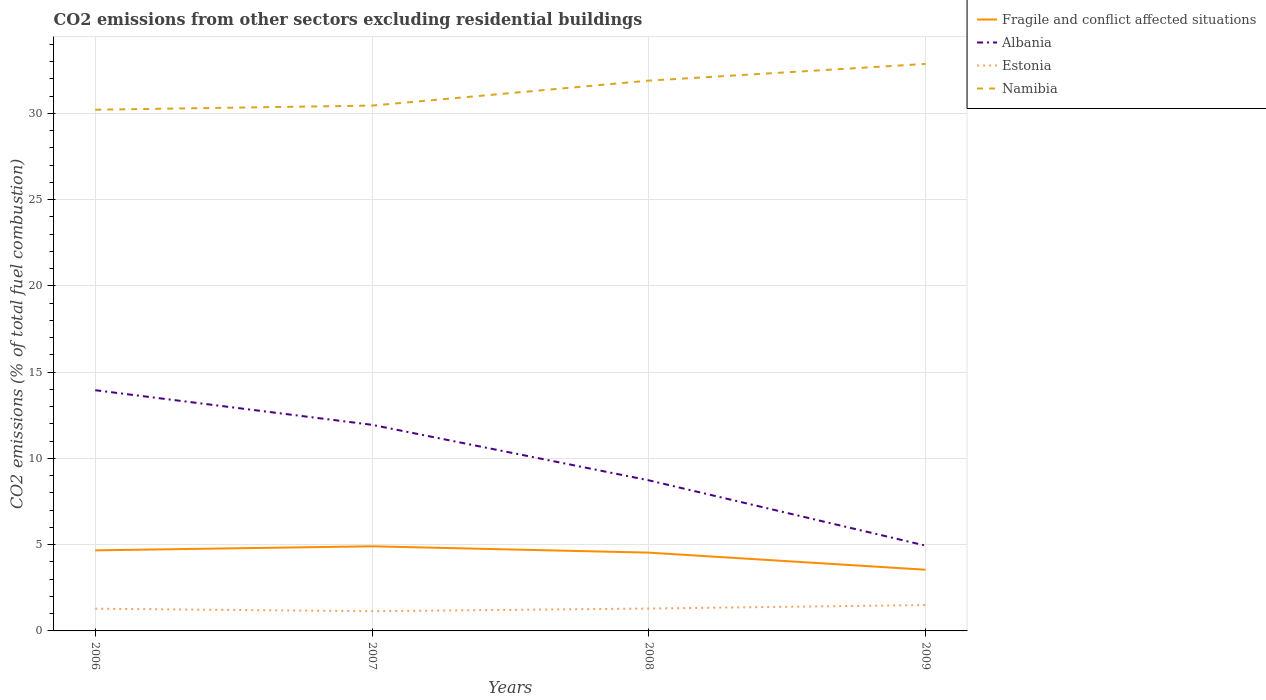How many different coloured lines are there?
Make the answer very short. 4. Does the line corresponding to Fragile and conflict affected situations intersect with the line corresponding to Namibia?
Your answer should be very brief. No. Is the number of lines equal to the number of legend labels?
Provide a succinct answer. Yes. Across all years, what is the maximum total CO2 emitted in Estonia?
Provide a succinct answer. 1.14. In which year was the total CO2 emitted in Namibia maximum?
Provide a succinct answer. 2006. What is the total total CO2 emitted in Estonia in the graph?
Your response must be concise. -0.01. What is the difference between the highest and the second highest total CO2 emitted in Namibia?
Your response must be concise. 2.65. What is the difference between the highest and the lowest total CO2 emitted in Estonia?
Your answer should be very brief. 1. Is the total CO2 emitted in Namibia strictly greater than the total CO2 emitted in Fragile and conflict affected situations over the years?
Your answer should be very brief. No. How many years are there in the graph?
Ensure brevity in your answer.  4. What is the difference between two consecutive major ticks on the Y-axis?
Ensure brevity in your answer.  5. Does the graph contain grids?
Your answer should be compact. Yes. How many legend labels are there?
Provide a succinct answer. 4. What is the title of the graph?
Your answer should be compact. CO2 emissions from other sectors excluding residential buildings. Does "Malawi" appear as one of the legend labels in the graph?
Provide a short and direct response. No. What is the label or title of the Y-axis?
Ensure brevity in your answer.  CO2 emissions (% of total fuel combustion). What is the CO2 emissions (% of total fuel combustion) of Fragile and conflict affected situations in 2006?
Your answer should be very brief. 4.67. What is the CO2 emissions (% of total fuel combustion) of Albania in 2006?
Ensure brevity in your answer.  13.95. What is the CO2 emissions (% of total fuel combustion) of Estonia in 2006?
Your answer should be compact. 1.29. What is the CO2 emissions (% of total fuel combustion) of Namibia in 2006?
Keep it short and to the point. 30.21. What is the CO2 emissions (% of total fuel combustion) of Fragile and conflict affected situations in 2007?
Give a very brief answer. 4.91. What is the CO2 emissions (% of total fuel combustion) of Albania in 2007?
Offer a terse response. 11.95. What is the CO2 emissions (% of total fuel combustion) in Estonia in 2007?
Provide a short and direct response. 1.14. What is the CO2 emissions (% of total fuel combustion) in Namibia in 2007?
Keep it short and to the point. 30.45. What is the CO2 emissions (% of total fuel combustion) of Fragile and conflict affected situations in 2008?
Give a very brief answer. 4.54. What is the CO2 emissions (% of total fuel combustion) in Albania in 2008?
Make the answer very short. 8.73. What is the CO2 emissions (% of total fuel combustion) in Estonia in 2008?
Give a very brief answer. 1.3. What is the CO2 emissions (% of total fuel combustion) of Namibia in 2008?
Offer a very short reply. 31.9. What is the CO2 emissions (% of total fuel combustion) in Fragile and conflict affected situations in 2009?
Your answer should be very brief. 3.55. What is the CO2 emissions (% of total fuel combustion) of Albania in 2009?
Offer a very short reply. 4.95. What is the CO2 emissions (% of total fuel combustion) of Estonia in 2009?
Make the answer very short. 1.5. What is the CO2 emissions (% of total fuel combustion) in Namibia in 2009?
Keep it short and to the point. 32.87. Across all years, what is the maximum CO2 emissions (% of total fuel combustion) of Fragile and conflict affected situations?
Your response must be concise. 4.91. Across all years, what is the maximum CO2 emissions (% of total fuel combustion) of Albania?
Give a very brief answer. 13.95. Across all years, what is the maximum CO2 emissions (% of total fuel combustion) of Estonia?
Your answer should be very brief. 1.5. Across all years, what is the maximum CO2 emissions (% of total fuel combustion) in Namibia?
Your answer should be very brief. 32.87. Across all years, what is the minimum CO2 emissions (% of total fuel combustion) of Fragile and conflict affected situations?
Ensure brevity in your answer.  3.55. Across all years, what is the minimum CO2 emissions (% of total fuel combustion) of Albania?
Your answer should be compact. 4.95. Across all years, what is the minimum CO2 emissions (% of total fuel combustion) in Estonia?
Offer a very short reply. 1.14. Across all years, what is the minimum CO2 emissions (% of total fuel combustion) in Namibia?
Keep it short and to the point. 30.21. What is the total CO2 emissions (% of total fuel combustion) of Fragile and conflict affected situations in the graph?
Your answer should be compact. 17.66. What is the total CO2 emissions (% of total fuel combustion) in Albania in the graph?
Offer a terse response. 39.58. What is the total CO2 emissions (% of total fuel combustion) in Estonia in the graph?
Give a very brief answer. 5.23. What is the total CO2 emissions (% of total fuel combustion) in Namibia in the graph?
Make the answer very short. 125.43. What is the difference between the CO2 emissions (% of total fuel combustion) of Fragile and conflict affected situations in 2006 and that in 2007?
Your answer should be very brief. -0.23. What is the difference between the CO2 emissions (% of total fuel combustion) of Albania in 2006 and that in 2007?
Ensure brevity in your answer.  2.01. What is the difference between the CO2 emissions (% of total fuel combustion) of Estonia in 2006 and that in 2007?
Provide a short and direct response. 0.15. What is the difference between the CO2 emissions (% of total fuel combustion) in Namibia in 2006 and that in 2007?
Your answer should be compact. -0.24. What is the difference between the CO2 emissions (% of total fuel combustion) in Fragile and conflict affected situations in 2006 and that in 2008?
Keep it short and to the point. 0.13. What is the difference between the CO2 emissions (% of total fuel combustion) in Albania in 2006 and that in 2008?
Make the answer very short. 5.22. What is the difference between the CO2 emissions (% of total fuel combustion) of Estonia in 2006 and that in 2008?
Provide a succinct answer. -0.01. What is the difference between the CO2 emissions (% of total fuel combustion) in Namibia in 2006 and that in 2008?
Ensure brevity in your answer.  -1.69. What is the difference between the CO2 emissions (% of total fuel combustion) of Fragile and conflict affected situations in 2006 and that in 2009?
Provide a succinct answer. 1.12. What is the difference between the CO2 emissions (% of total fuel combustion) in Albania in 2006 and that in 2009?
Give a very brief answer. 9.01. What is the difference between the CO2 emissions (% of total fuel combustion) in Estonia in 2006 and that in 2009?
Your answer should be compact. -0.21. What is the difference between the CO2 emissions (% of total fuel combustion) of Namibia in 2006 and that in 2009?
Provide a short and direct response. -2.65. What is the difference between the CO2 emissions (% of total fuel combustion) of Fragile and conflict affected situations in 2007 and that in 2008?
Your answer should be compact. 0.37. What is the difference between the CO2 emissions (% of total fuel combustion) in Albania in 2007 and that in 2008?
Your answer should be very brief. 3.22. What is the difference between the CO2 emissions (% of total fuel combustion) in Estonia in 2007 and that in 2008?
Provide a succinct answer. -0.16. What is the difference between the CO2 emissions (% of total fuel combustion) of Namibia in 2007 and that in 2008?
Your response must be concise. -1.45. What is the difference between the CO2 emissions (% of total fuel combustion) in Fragile and conflict affected situations in 2007 and that in 2009?
Provide a succinct answer. 1.36. What is the difference between the CO2 emissions (% of total fuel combustion) of Albania in 2007 and that in 2009?
Your answer should be compact. 7. What is the difference between the CO2 emissions (% of total fuel combustion) of Estonia in 2007 and that in 2009?
Make the answer very short. -0.36. What is the difference between the CO2 emissions (% of total fuel combustion) of Namibia in 2007 and that in 2009?
Keep it short and to the point. -2.41. What is the difference between the CO2 emissions (% of total fuel combustion) of Albania in 2008 and that in 2009?
Provide a succinct answer. 3.79. What is the difference between the CO2 emissions (% of total fuel combustion) of Estonia in 2008 and that in 2009?
Ensure brevity in your answer.  -0.2. What is the difference between the CO2 emissions (% of total fuel combustion) of Namibia in 2008 and that in 2009?
Ensure brevity in your answer.  -0.97. What is the difference between the CO2 emissions (% of total fuel combustion) of Fragile and conflict affected situations in 2006 and the CO2 emissions (% of total fuel combustion) of Albania in 2007?
Provide a short and direct response. -7.28. What is the difference between the CO2 emissions (% of total fuel combustion) in Fragile and conflict affected situations in 2006 and the CO2 emissions (% of total fuel combustion) in Estonia in 2007?
Your answer should be very brief. 3.53. What is the difference between the CO2 emissions (% of total fuel combustion) in Fragile and conflict affected situations in 2006 and the CO2 emissions (% of total fuel combustion) in Namibia in 2007?
Give a very brief answer. -25.78. What is the difference between the CO2 emissions (% of total fuel combustion) in Albania in 2006 and the CO2 emissions (% of total fuel combustion) in Estonia in 2007?
Keep it short and to the point. 12.81. What is the difference between the CO2 emissions (% of total fuel combustion) of Albania in 2006 and the CO2 emissions (% of total fuel combustion) of Namibia in 2007?
Offer a very short reply. -16.5. What is the difference between the CO2 emissions (% of total fuel combustion) in Estonia in 2006 and the CO2 emissions (% of total fuel combustion) in Namibia in 2007?
Keep it short and to the point. -29.16. What is the difference between the CO2 emissions (% of total fuel combustion) in Fragile and conflict affected situations in 2006 and the CO2 emissions (% of total fuel combustion) in Albania in 2008?
Keep it short and to the point. -4.06. What is the difference between the CO2 emissions (% of total fuel combustion) in Fragile and conflict affected situations in 2006 and the CO2 emissions (% of total fuel combustion) in Estonia in 2008?
Your answer should be very brief. 3.37. What is the difference between the CO2 emissions (% of total fuel combustion) of Fragile and conflict affected situations in 2006 and the CO2 emissions (% of total fuel combustion) of Namibia in 2008?
Offer a terse response. -27.23. What is the difference between the CO2 emissions (% of total fuel combustion) of Albania in 2006 and the CO2 emissions (% of total fuel combustion) of Estonia in 2008?
Give a very brief answer. 12.66. What is the difference between the CO2 emissions (% of total fuel combustion) in Albania in 2006 and the CO2 emissions (% of total fuel combustion) in Namibia in 2008?
Keep it short and to the point. -17.95. What is the difference between the CO2 emissions (% of total fuel combustion) in Estonia in 2006 and the CO2 emissions (% of total fuel combustion) in Namibia in 2008?
Your answer should be compact. -30.61. What is the difference between the CO2 emissions (% of total fuel combustion) in Fragile and conflict affected situations in 2006 and the CO2 emissions (% of total fuel combustion) in Albania in 2009?
Make the answer very short. -0.27. What is the difference between the CO2 emissions (% of total fuel combustion) in Fragile and conflict affected situations in 2006 and the CO2 emissions (% of total fuel combustion) in Estonia in 2009?
Make the answer very short. 3.17. What is the difference between the CO2 emissions (% of total fuel combustion) of Fragile and conflict affected situations in 2006 and the CO2 emissions (% of total fuel combustion) of Namibia in 2009?
Your answer should be very brief. -28.2. What is the difference between the CO2 emissions (% of total fuel combustion) in Albania in 2006 and the CO2 emissions (% of total fuel combustion) in Estonia in 2009?
Offer a terse response. 12.45. What is the difference between the CO2 emissions (% of total fuel combustion) in Albania in 2006 and the CO2 emissions (% of total fuel combustion) in Namibia in 2009?
Your response must be concise. -18.91. What is the difference between the CO2 emissions (% of total fuel combustion) in Estonia in 2006 and the CO2 emissions (% of total fuel combustion) in Namibia in 2009?
Give a very brief answer. -31.58. What is the difference between the CO2 emissions (% of total fuel combustion) in Fragile and conflict affected situations in 2007 and the CO2 emissions (% of total fuel combustion) in Albania in 2008?
Provide a short and direct response. -3.82. What is the difference between the CO2 emissions (% of total fuel combustion) of Fragile and conflict affected situations in 2007 and the CO2 emissions (% of total fuel combustion) of Estonia in 2008?
Your answer should be very brief. 3.61. What is the difference between the CO2 emissions (% of total fuel combustion) of Fragile and conflict affected situations in 2007 and the CO2 emissions (% of total fuel combustion) of Namibia in 2008?
Make the answer very short. -26.99. What is the difference between the CO2 emissions (% of total fuel combustion) in Albania in 2007 and the CO2 emissions (% of total fuel combustion) in Estonia in 2008?
Your answer should be compact. 10.65. What is the difference between the CO2 emissions (% of total fuel combustion) in Albania in 2007 and the CO2 emissions (% of total fuel combustion) in Namibia in 2008?
Your answer should be compact. -19.95. What is the difference between the CO2 emissions (% of total fuel combustion) in Estonia in 2007 and the CO2 emissions (% of total fuel combustion) in Namibia in 2008?
Your answer should be compact. -30.76. What is the difference between the CO2 emissions (% of total fuel combustion) in Fragile and conflict affected situations in 2007 and the CO2 emissions (% of total fuel combustion) in Albania in 2009?
Your answer should be very brief. -0.04. What is the difference between the CO2 emissions (% of total fuel combustion) in Fragile and conflict affected situations in 2007 and the CO2 emissions (% of total fuel combustion) in Estonia in 2009?
Offer a very short reply. 3.41. What is the difference between the CO2 emissions (% of total fuel combustion) of Fragile and conflict affected situations in 2007 and the CO2 emissions (% of total fuel combustion) of Namibia in 2009?
Give a very brief answer. -27.96. What is the difference between the CO2 emissions (% of total fuel combustion) of Albania in 2007 and the CO2 emissions (% of total fuel combustion) of Estonia in 2009?
Keep it short and to the point. 10.45. What is the difference between the CO2 emissions (% of total fuel combustion) in Albania in 2007 and the CO2 emissions (% of total fuel combustion) in Namibia in 2009?
Provide a succinct answer. -20.92. What is the difference between the CO2 emissions (% of total fuel combustion) in Estonia in 2007 and the CO2 emissions (% of total fuel combustion) in Namibia in 2009?
Offer a terse response. -31.72. What is the difference between the CO2 emissions (% of total fuel combustion) in Fragile and conflict affected situations in 2008 and the CO2 emissions (% of total fuel combustion) in Albania in 2009?
Provide a short and direct response. -0.41. What is the difference between the CO2 emissions (% of total fuel combustion) in Fragile and conflict affected situations in 2008 and the CO2 emissions (% of total fuel combustion) in Estonia in 2009?
Your answer should be compact. 3.04. What is the difference between the CO2 emissions (% of total fuel combustion) in Fragile and conflict affected situations in 2008 and the CO2 emissions (% of total fuel combustion) in Namibia in 2009?
Provide a succinct answer. -28.33. What is the difference between the CO2 emissions (% of total fuel combustion) of Albania in 2008 and the CO2 emissions (% of total fuel combustion) of Estonia in 2009?
Make the answer very short. 7.23. What is the difference between the CO2 emissions (% of total fuel combustion) of Albania in 2008 and the CO2 emissions (% of total fuel combustion) of Namibia in 2009?
Ensure brevity in your answer.  -24.14. What is the difference between the CO2 emissions (% of total fuel combustion) of Estonia in 2008 and the CO2 emissions (% of total fuel combustion) of Namibia in 2009?
Provide a short and direct response. -31.57. What is the average CO2 emissions (% of total fuel combustion) in Fragile and conflict affected situations per year?
Give a very brief answer. 4.42. What is the average CO2 emissions (% of total fuel combustion) of Albania per year?
Offer a terse response. 9.89. What is the average CO2 emissions (% of total fuel combustion) of Estonia per year?
Keep it short and to the point. 1.31. What is the average CO2 emissions (% of total fuel combustion) in Namibia per year?
Provide a short and direct response. 31.36. In the year 2006, what is the difference between the CO2 emissions (% of total fuel combustion) in Fragile and conflict affected situations and CO2 emissions (% of total fuel combustion) in Albania?
Keep it short and to the point. -9.28. In the year 2006, what is the difference between the CO2 emissions (% of total fuel combustion) in Fragile and conflict affected situations and CO2 emissions (% of total fuel combustion) in Estonia?
Make the answer very short. 3.38. In the year 2006, what is the difference between the CO2 emissions (% of total fuel combustion) of Fragile and conflict affected situations and CO2 emissions (% of total fuel combustion) of Namibia?
Provide a short and direct response. -25.54. In the year 2006, what is the difference between the CO2 emissions (% of total fuel combustion) of Albania and CO2 emissions (% of total fuel combustion) of Estonia?
Your response must be concise. 12.67. In the year 2006, what is the difference between the CO2 emissions (% of total fuel combustion) of Albania and CO2 emissions (% of total fuel combustion) of Namibia?
Keep it short and to the point. -16.26. In the year 2006, what is the difference between the CO2 emissions (% of total fuel combustion) of Estonia and CO2 emissions (% of total fuel combustion) of Namibia?
Your answer should be very brief. -28.92. In the year 2007, what is the difference between the CO2 emissions (% of total fuel combustion) of Fragile and conflict affected situations and CO2 emissions (% of total fuel combustion) of Albania?
Offer a very short reply. -7.04. In the year 2007, what is the difference between the CO2 emissions (% of total fuel combustion) in Fragile and conflict affected situations and CO2 emissions (% of total fuel combustion) in Estonia?
Offer a terse response. 3.76. In the year 2007, what is the difference between the CO2 emissions (% of total fuel combustion) in Fragile and conflict affected situations and CO2 emissions (% of total fuel combustion) in Namibia?
Offer a terse response. -25.55. In the year 2007, what is the difference between the CO2 emissions (% of total fuel combustion) in Albania and CO2 emissions (% of total fuel combustion) in Estonia?
Ensure brevity in your answer.  10.81. In the year 2007, what is the difference between the CO2 emissions (% of total fuel combustion) in Albania and CO2 emissions (% of total fuel combustion) in Namibia?
Keep it short and to the point. -18.5. In the year 2007, what is the difference between the CO2 emissions (% of total fuel combustion) of Estonia and CO2 emissions (% of total fuel combustion) of Namibia?
Keep it short and to the point. -29.31. In the year 2008, what is the difference between the CO2 emissions (% of total fuel combustion) in Fragile and conflict affected situations and CO2 emissions (% of total fuel combustion) in Albania?
Give a very brief answer. -4.19. In the year 2008, what is the difference between the CO2 emissions (% of total fuel combustion) of Fragile and conflict affected situations and CO2 emissions (% of total fuel combustion) of Estonia?
Offer a terse response. 3.24. In the year 2008, what is the difference between the CO2 emissions (% of total fuel combustion) in Fragile and conflict affected situations and CO2 emissions (% of total fuel combustion) in Namibia?
Keep it short and to the point. -27.36. In the year 2008, what is the difference between the CO2 emissions (% of total fuel combustion) in Albania and CO2 emissions (% of total fuel combustion) in Estonia?
Provide a short and direct response. 7.43. In the year 2008, what is the difference between the CO2 emissions (% of total fuel combustion) of Albania and CO2 emissions (% of total fuel combustion) of Namibia?
Offer a very short reply. -23.17. In the year 2008, what is the difference between the CO2 emissions (% of total fuel combustion) of Estonia and CO2 emissions (% of total fuel combustion) of Namibia?
Your answer should be very brief. -30.6. In the year 2009, what is the difference between the CO2 emissions (% of total fuel combustion) in Fragile and conflict affected situations and CO2 emissions (% of total fuel combustion) in Albania?
Offer a very short reply. -1.4. In the year 2009, what is the difference between the CO2 emissions (% of total fuel combustion) in Fragile and conflict affected situations and CO2 emissions (% of total fuel combustion) in Estonia?
Your answer should be compact. 2.05. In the year 2009, what is the difference between the CO2 emissions (% of total fuel combustion) in Fragile and conflict affected situations and CO2 emissions (% of total fuel combustion) in Namibia?
Ensure brevity in your answer.  -29.32. In the year 2009, what is the difference between the CO2 emissions (% of total fuel combustion) in Albania and CO2 emissions (% of total fuel combustion) in Estonia?
Give a very brief answer. 3.45. In the year 2009, what is the difference between the CO2 emissions (% of total fuel combustion) of Albania and CO2 emissions (% of total fuel combustion) of Namibia?
Provide a succinct answer. -27.92. In the year 2009, what is the difference between the CO2 emissions (% of total fuel combustion) of Estonia and CO2 emissions (% of total fuel combustion) of Namibia?
Provide a short and direct response. -31.37. What is the ratio of the CO2 emissions (% of total fuel combustion) of Fragile and conflict affected situations in 2006 to that in 2007?
Offer a terse response. 0.95. What is the ratio of the CO2 emissions (% of total fuel combustion) in Albania in 2006 to that in 2007?
Provide a succinct answer. 1.17. What is the ratio of the CO2 emissions (% of total fuel combustion) of Estonia in 2006 to that in 2007?
Make the answer very short. 1.13. What is the ratio of the CO2 emissions (% of total fuel combustion) of Namibia in 2006 to that in 2007?
Keep it short and to the point. 0.99. What is the ratio of the CO2 emissions (% of total fuel combustion) in Fragile and conflict affected situations in 2006 to that in 2008?
Offer a terse response. 1.03. What is the ratio of the CO2 emissions (% of total fuel combustion) in Albania in 2006 to that in 2008?
Provide a short and direct response. 1.6. What is the ratio of the CO2 emissions (% of total fuel combustion) in Estonia in 2006 to that in 2008?
Offer a terse response. 0.99. What is the ratio of the CO2 emissions (% of total fuel combustion) in Namibia in 2006 to that in 2008?
Provide a succinct answer. 0.95. What is the ratio of the CO2 emissions (% of total fuel combustion) in Fragile and conflict affected situations in 2006 to that in 2009?
Provide a succinct answer. 1.32. What is the ratio of the CO2 emissions (% of total fuel combustion) in Albania in 2006 to that in 2009?
Provide a short and direct response. 2.82. What is the ratio of the CO2 emissions (% of total fuel combustion) in Estonia in 2006 to that in 2009?
Make the answer very short. 0.86. What is the ratio of the CO2 emissions (% of total fuel combustion) of Namibia in 2006 to that in 2009?
Provide a short and direct response. 0.92. What is the ratio of the CO2 emissions (% of total fuel combustion) of Fragile and conflict affected situations in 2007 to that in 2008?
Provide a succinct answer. 1.08. What is the ratio of the CO2 emissions (% of total fuel combustion) of Albania in 2007 to that in 2008?
Your answer should be very brief. 1.37. What is the ratio of the CO2 emissions (% of total fuel combustion) of Namibia in 2007 to that in 2008?
Your response must be concise. 0.95. What is the ratio of the CO2 emissions (% of total fuel combustion) of Fragile and conflict affected situations in 2007 to that in 2009?
Ensure brevity in your answer.  1.38. What is the ratio of the CO2 emissions (% of total fuel combustion) in Albania in 2007 to that in 2009?
Ensure brevity in your answer.  2.42. What is the ratio of the CO2 emissions (% of total fuel combustion) in Estonia in 2007 to that in 2009?
Give a very brief answer. 0.76. What is the ratio of the CO2 emissions (% of total fuel combustion) of Namibia in 2007 to that in 2009?
Your response must be concise. 0.93. What is the ratio of the CO2 emissions (% of total fuel combustion) of Fragile and conflict affected situations in 2008 to that in 2009?
Keep it short and to the point. 1.28. What is the ratio of the CO2 emissions (% of total fuel combustion) in Albania in 2008 to that in 2009?
Your answer should be very brief. 1.77. What is the ratio of the CO2 emissions (% of total fuel combustion) in Estonia in 2008 to that in 2009?
Your answer should be very brief. 0.87. What is the ratio of the CO2 emissions (% of total fuel combustion) of Namibia in 2008 to that in 2009?
Offer a terse response. 0.97. What is the difference between the highest and the second highest CO2 emissions (% of total fuel combustion) in Fragile and conflict affected situations?
Give a very brief answer. 0.23. What is the difference between the highest and the second highest CO2 emissions (% of total fuel combustion) of Albania?
Keep it short and to the point. 2.01. What is the difference between the highest and the second highest CO2 emissions (% of total fuel combustion) of Estonia?
Provide a short and direct response. 0.2. What is the difference between the highest and the second highest CO2 emissions (% of total fuel combustion) in Namibia?
Offer a very short reply. 0.97. What is the difference between the highest and the lowest CO2 emissions (% of total fuel combustion) of Fragile and conflict affected situations?
Your answer should be very brief. 1.36. What is the difference between the highest and the lowest CO2 emissions (% of total fuel combustion) in Albania?
Your answer should be compact. 9.01. What is the difference between the highest and the lowest CO2 emissions (% of total fuel combustion) of Estonia?
Provide a short and direct response. 0.36. What is the difference between the highest and the lowest CO2 emissions (% of total fuel combustion) in Namibia?
Your response must be concise. 2.65. 